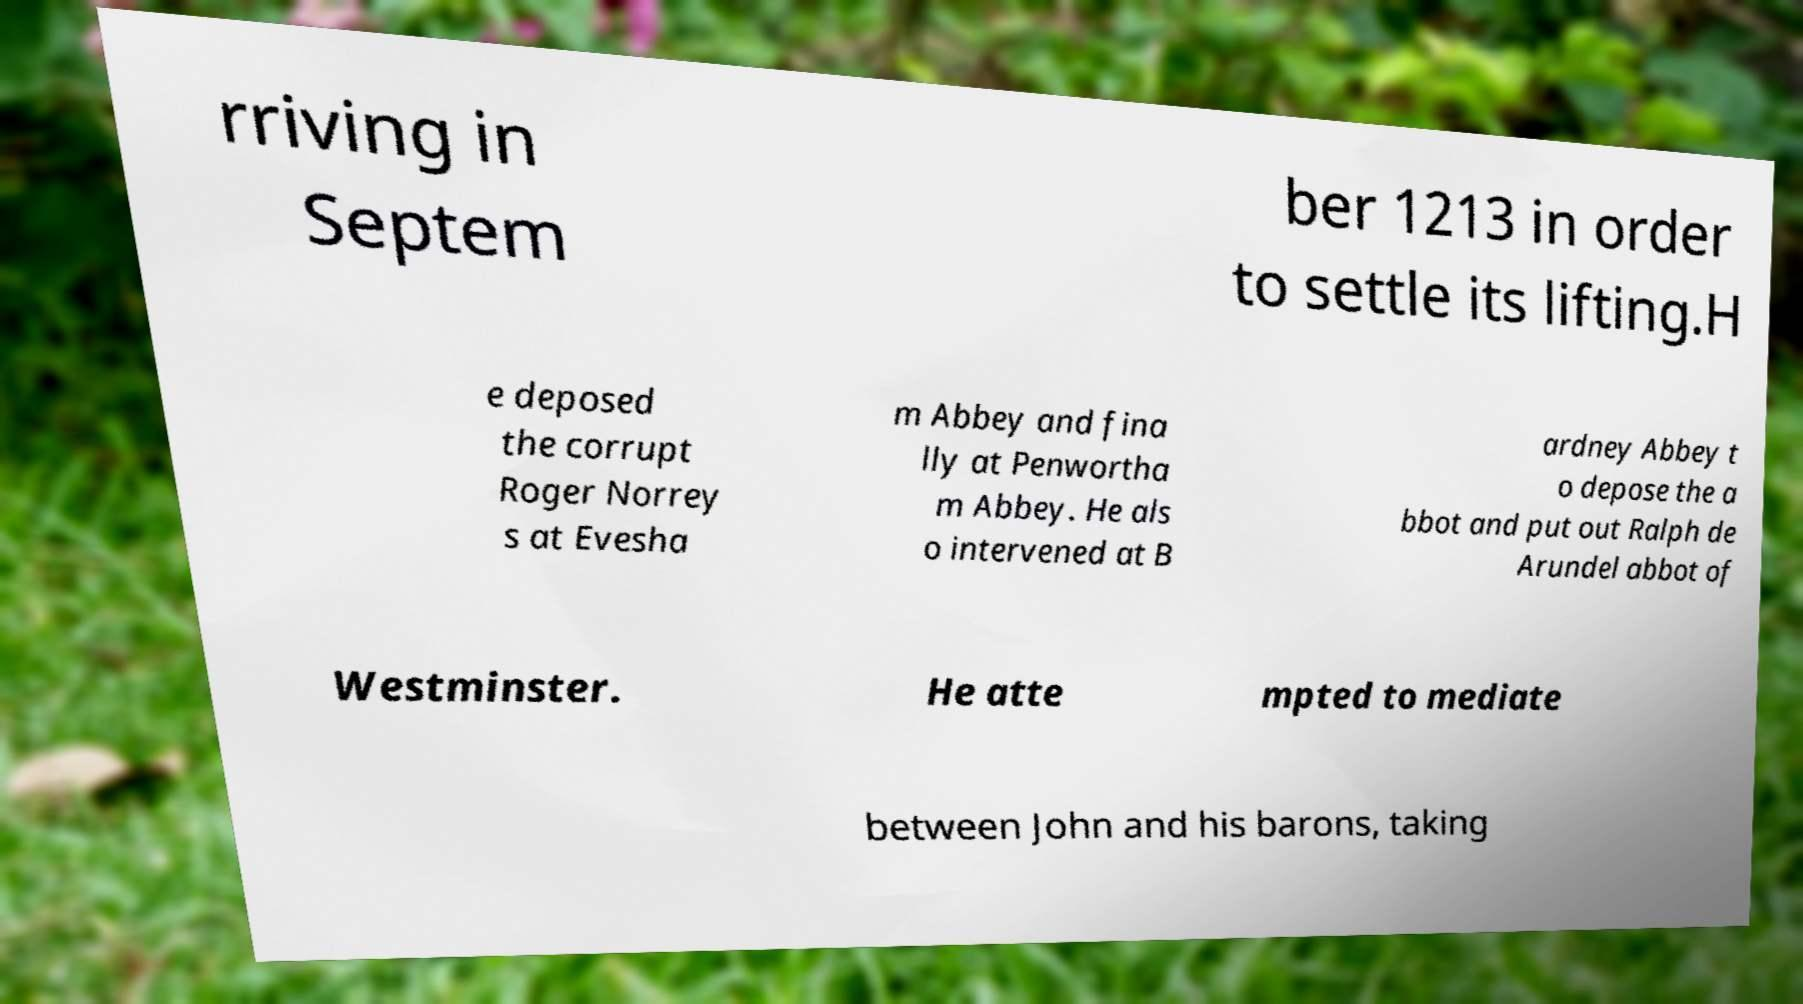Could you assist in decoding the text presented in this image and type it out clearly? rriving in Septem ber 1213 in order to settle its lifting.H e deposed the corrupt Roger Norrey s at Evesha m Abbey and fina lly at Penwortha m Abbey. He als o intervened at B ardney Abbey t o depose the a bbot and put out Ralph de Arundel abbot of Westminster. He atte mpted to mediate between John and his barons, taking 